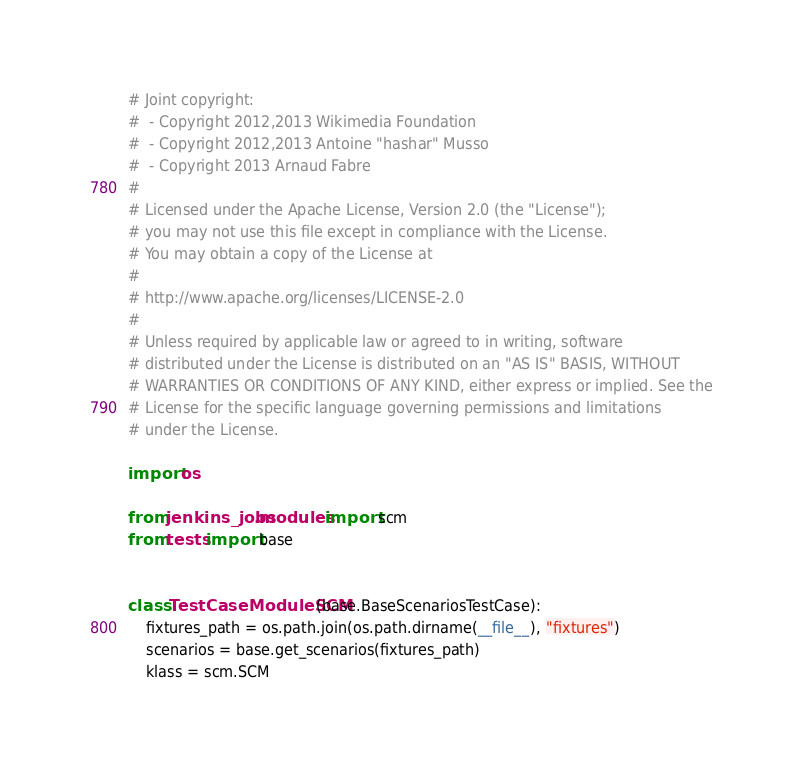<code> <loc_0><loc_0><loc_500><loc_500><_Python_># Joint copyright:
#  - Copyright 2012,2013 Wikimedia Foundation
#  - Copyright 2012,2013 Antoine "hashar" Musso
#  - Copyright 2013 Arnaud Fabre
#
# Licensed under the Apache License, Version 2.0 (the "License");
# you may not use this file except in compliance with the License.
# You may obtain a copy of the License at
#
# http://www.apache.org/licenses/LICENSE-2.0
#
# Unless required by applicable law or agreed to in writing, software
# distributed under the License is distributed on an "AS IS" BASIS, WITHOUT
# WARRANTIES OR CONDITIONS OF ANY KIND, either express or implied. See the
# License for the specific language governing permissions and limitations
# under the License.

import os

from jenkins_jobs.modules import scm
from tests import base


class TestCaseModuleSCM(base.BaseScenariosTestCase):
    fixtures_path = os.path.join(os.path.dirname(__file__), "fixtures")
    scenarios = base.get_scenarios(fixtures_path)
    klass = scm.SCM
</code> 